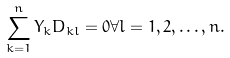<formula> <loc_0><loc_0><loc_500><loc_500>\sum _ { k = 1 } ^ { n } Y _ { k } D _ { k l } = 0 \forall l = 1 , 2 , \dots , n .</formula> 